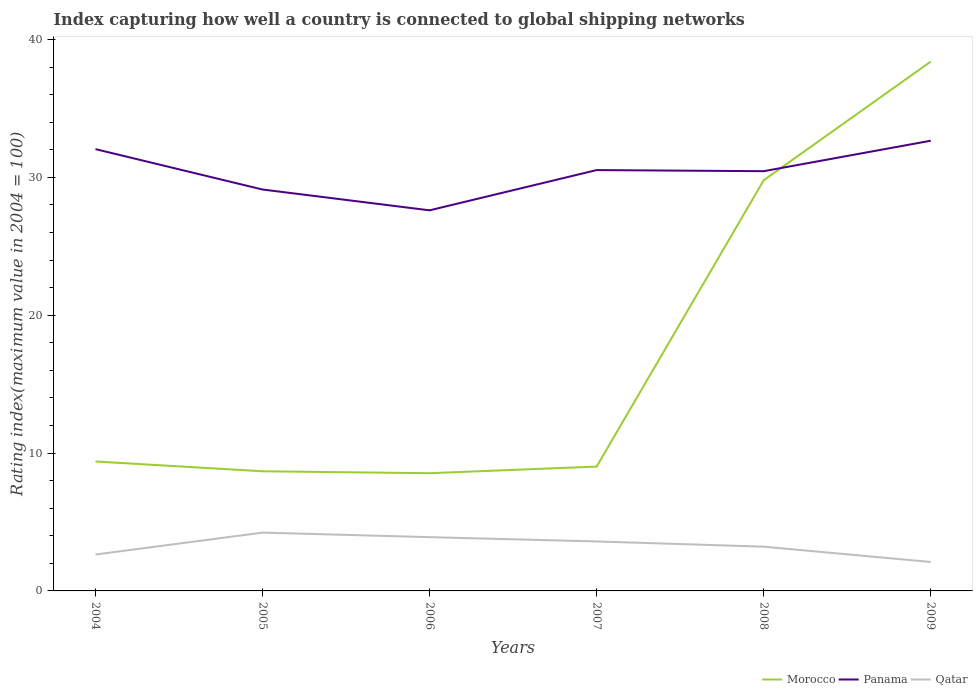How many different coloured lines are there?
Ensure brevity in your answer.  3. Does the line corresponding to Morocco intersect with the line corresponding to Panama?
Provide a succinct answer. Yes. Is the number of lines equal to the number of legend labels?
Your answer should be very brief. Yes. Across all years, what is the maximum rating index in Panama?
Make the answer very short. 27.61. In which year was the rating index in Panama maximum?
Ensure brevity in your answer.  2006. What is the total rating index in Panama in the graph?
Offer a terse response. -2.92. What is the difference between the highest and the second highest rating index in Qatar?
Your response must be concise. 2.13. What is the difference between the highest and the lowest rating index in Qatar?
Offer a very short reply. 3. Is the rating index in Morocco strictly greater than the rating index in Panama over the years?
Keep it short and to the point. No. How many years are there in the graph?
Offer a terse response. 6. What is the difference between two consecutive major ticks on the Y-axis?
Keep it short and to the point. 10. Are the values on the major ticks of Y-axis written in scientific E-notation?
Your response must be concise. No. Does the graph contain grids?
Offer a terse response. No. How many legend labels are there?
Offer a very short reply. 3. How are the legend labels stacked?
Give a very brief answer. Horizontal. What is the title of the graph?
Keep it short and to the point. Index capturing how well a country is connected to global shipping networks. What is the label or title of the X-axis?
Provide a short and direct response. Years. What is the label or title of the Y-axis?
Ensure brevity in your answer.  Rating index(maximum value in 2004 = 100). What is the Rating index(maximum value in 2004 = 100) of Morocco in 2004?
Provide a succinct answer. 9.39. What is the Rating index(maximum value in 2004 = 100) of Panama in 2004?
Offer a terse response. 32.05. What is the Rating index(maximum value in 2004 = 100) of Qatar in 2004?
Your answer should be very brief. 2.64. What is the Rating index(maximum value in 2004 = 100) in Morocco in 2005?
Provide a succinct answer. 8.68. What is the Rating index(maximum value in 2004 = 100) in Panama in 2005?
Offer a very short reply. 29.12. What is the Rating index(maximum value in 2004 = 100) in Qatar in 2005?
Give a very brief answer. 4.23. What is the Rating index(maximum value in 2004 = 100) of Morocco in 2006?
Your answer should be very brief. 8.54. What is the Rating index(maximum value in 2004 = 100) in Panama in 2006?
Offer a very short reply. 27.61. What is the Rating index(maximum value in 2004 = 100) of Qatar in 2006?
Your response must be concise. 3.9. What is the Rating index(maximum value in 2004 = 100) of Morocco in 2007?
Your answer should be very brief. 9.02. What is the Rating index(maximum value in 2004 = 100) of Panama in 2007?
Provide a short and direct response. 30.53. What is the Rating index(maximum value in 2004 = 100) in Qatar in 2007?
Keep it short and to the point. 3.59. What is the Rating index(maximum value in 2004 = 100) in Morocco in 2008?
Give a very brief answer. 29.79. What is the Rating index(maximum value in 2004 = 100) in Panama in 2008?
Make the answer very short. 30.45. What is the Rating index(maximum value in 2004 = 100) of Qatar in 2008?
Your response must be concise. 3.21. What is the Rating index(maximum value in 2004 = 100) of Morocco in 2009?
Offer a very short reply. 38.4. What is the Rating index(maximum value in 2004 = 100) in Panama in 2009?
Keep it short and to the point. 32.66. What is the Rating index(maximum value in 2004 = 100) of Qatar in 2009?
Your answer should be very brief. 2.1. Across all years, what is the maximum Rating index(maximum value in 2004 = 100) of Morocco?
Provide a short and direct response. 38.4. Across all years, what is the maximum Rating index(maximum value in 2004 = 100) of Panama?
Ensure brevity in your answer.  32.66. Across all years, what is the maximum Rating index(maximum value in 2004 = 100) in Qatar?
Give a very brief answer. 4.23. Across all years, what is the minimum Rating index(maximum value in 2004 = 100) in Morocco?
Provide a succinct answer. 8.54. Across all years, what is the minimum Rating index(maximum value in 2004 = 100) of Panama?
Keep it short and to the point. 27.61. What is the total Rating index(maximum value in 2004 = 100) in Morocco in the graph?
Provide a short and direct response. 103.82. What is the total Rating index(maximum value in 2004 = 100) of Panama in the graph?
Offer a terse response. 182.42. What is the total Rating index(maximum value in 2004 = 100) in Qatar in the graph?
Keep it short and to the point. 19.67. What is the difference between the Rating index(maximum value in 2004 = 100) of Morocco in 2004 and that in 2005?
Keep it short and to the point. 0.71. What is the difference between the Rating index(maximum value in 2004 = 100) in Panama in 2004 and that in 2005?
Give a very brief answer. 2.93. What is the difference between the Rating index(maximum value in 2004 = 100) in Qatar in 2004 and that in 2005?
Offer a terse response. -1.59. What is the difference between the Rating index(maximum value in 2004 = 100) of Panama in 2004 and that in 2006?
Your answer should be very brief. 4.44. What is the difference between the Rating index(maximum value in 2004 = 100) of Qatar in 2004 and that in 2006?
Offer a very short reply. -1.26. What is the difference between the Rating index(maximum value in 2004 = 100) in Morocco in 2004 and that in 2007?
Ensure brevity in your answer.  0.37. What is the difference between the Rating index(maximum value in 2004 = 100) in Panama in 2004 and that in 2007?
Offer a terse response. 1.52. What is the difference between the Rating index(maximum value in 2004 = 100) in Qatar in 2004 and that in 2007?
Your answer should be compact. -0.95. What is the difference between the Rating index(maximum value in 2004 = 100) of Morocco in 2004 and that in 2008?
Offer a very short reply. -20.4. What is the difference between the Rating index(maximum value in 2004 = 100) of Qatar in 2004 and that in 2008?
Offer a very short reply. -0.57. What is the difference between the Rating index(maximum value in 2004 = 100) of Morocco in 2004 and that in 2009?
Your answer should be very brief. -29.01. What is the difference between the Rating index(maximum value in 2004 = 100) of Panama in 2004 and that in 2009?
Provide a short and direct response. -0.61. What is the difference between the Rating index(maximum value in 2004 = 100) in Qatar in 2004 and that in 2009?
Your answer should be very brief. 0.54. What is the difference between the Rating index(maximum value in 2004 = 100) of Morocco in 2005 and that in 2006?
Give a very brief answer. 0.14. What is the difference between the Rating index(maximum value in 2004 = 100) of Panama in 2005 and that in 2006?
Give a very brief answer. 1.51. What is the difference between the Rating index(maximum value in 2004 = 100) of Qatar in 2005 and that in 2006?
Offer a terse response. 0.33. What is the difference between the Rating index(maximum value in 2004 = 100) of Morocco in 2005 and that in 2007?
Give a very brief answer. -0.34. What is the difference between the Rating index(maximum value in 2004 = 100) of Panama in 2005 and that in 2007?
Offer a very short reply. -1.41. What is the difference between the Rating index(maximum value in 2004 = 100) in Qatar in 2005 and that in 2007?
Give a very brief answer. 0.64. What is the difference between the Rating index(maximum value in 2004 = 100) in Morocco in 2005 and that in 2008?
Your answer should be very brief. -21.11. What is the difference between the Rating index(maximum value in 2004 = 100) in Panama in 2005 and that in 2008?
Your answer should be compact. -1.33. What is the difference between the Rating index(maximum value in 2004 = 100) of Qatar in 2005 and that in 2008?
Provide a succinct answer. 1.02. What is the difference between the Rating index(maximum value in 2004 = 100) of Morocco in 2005 and that in 2009?
Keep it short and to the point. -29.72. What is the difference between the Rating index(maximum value in 2004 = 100) in Panama in 2005 and that in 2009?
Make the answer very short. -3.54. What is the difference between the Rating index(maximum value in 2004 = 100) in Qatar in 2005 and that in 2009?
Offer a terse response. 2.13. What is the difference between the Rating index(maximum value in 2004 = 100) in Morocco in 2006 and that in 2007?
Your response must be concise. -0.48. What is the difference between the Rating index(maximum value in 2004 = 100) of Panama in 2006 and that in 2007?
Keep it short and to the point. -2.92. What is the difference between the Rating index(maximum value in 2004 = 100) of Qatar in 2006 and that in 2007?
Offer a terse response. 0.31. What is the difference between the Rating index(maximum value in 2004 = 100) in Morocco in 2006 and that in 2008?
Your response must be concise. -21.25. What is the difference between the Rating index(maximum value in 2004 = 100) in Panama in 2006 and that in 2008?
Your response must be concise. -2.84. What is the difference between the Rating index(maximum value in 2004 = 100) in Qatar in 2006 and that in 2008?
Offer a terse response. 0.69. What is the difference between the Rating index(maximum value in 2004 = 100) of Morocco in 2006 and that in 2009?
Ensure brevity in your answer.  -29.86. What is the difference between the Rating index(maximum value in 2004 = 100) of Panama in 2006 and that in 2009?
Offer a very short reply. -5.05. What is the difference between the Rating index(maximum value in 2004 = 100) in Morocco in 2007 and that in 2008?
Ensure brevity in your answer.  -20.77. What is the difference between the Rating index(maximum value in 2004 = 100) in Qatar in 2007 and that in 2008?
Ensure brevity in your answer.  0.38. What is the difference between the Rating index(maximum value in 2004 = 100) in Morocco in 2007 and that in 2009?
Make the answer very short. -29.38. What is the difference between the Rating index(maximum value in 2004 = 100) of Panama in 2007 and that in 2009?
Offer a terse response. -2.13. What is the difference between the Rating index(maximum value in 2004 = 100) in Qatar in 2007 and that in 2009?
Ensure brevity in your answer.  1.49. What is the difference between the Rating index(maximum value in 2004 = 100) in Morocco in 2008 and that in 2009?
Provide a succinct answer. -8.61. What is the difference between the Rating index(maximum value in 2004 = 100) in Panama in 2008 and that in 2009?
Offer a terse response. -2.21. What is the difference between the Rating index(maximum value in 2004 = 100) of Qatar in 2008 and that in 2009?
Your answer should be very brief. 1.11. What is the difference between the Rating index(maximum value in 2004 = 100) in Morocco in 2004 and the Rating index(maximum value in 2004 = 100) in Panama in 2005?
Give a very brief answer. -19.73. What is the difference between the Rating index(maximum value in 2004 = 100) of Morocco in 2004 and the Rating index(maximum value in 2004 = 100) of Qatar in 2005?
Give a very brief answer. 5.16. What is the difference between the Rating index(maximum value in 2004 = 100) in Panama in 2004 and the Rating index(maximum value in 2004 = 100) in Qatar in 2005?
Your response must be concise. 27.82. What is the difference between the Rating index(maximum value in 2004 = 100) in Morocco in 2004 and the Rating index(maximum value in 2004 = 100) in Panama in 2006?
Your answer should be compact. -18.22. What is the difference between the Rating index(maximum value in 2004 = 100) of Morocco in 2004 and the Rating index(maximum value in 2004 = 100) of Qatar in 2006?
Provide a short and direct response. 5.49. What is the difference between the Rating index(maximum value in 2004 = 100) of Panama in 2004 and the Rating index(maximum value in 2004 = 100) of Qatar in 2006?
Provide a short and direct response. 28.15. What is the difference between the Rating index(maximum value in 2004 = 100) of Morocco in 2004 and the Rating index(maximum value in 2004 = 100) of Panama in 2007?
Keep it short and to the point. -21.14. What is the difference between the Rating index(maximum value in 2004 = 100) in Panama in 2004 and the Rating index(maximum value in 2004 = 100) in Qatar in 2007?
Your answer should be very brief. 28.46. What is the difference between the Rating index(maximum value in 2004 = 100) of Morocco in 2004 and the Rating index(maximum value in 2004 = 100) of Panama in 2008?
Offer a very short reply. -21.06. What is the difference between the Rating index(maximum value in 2004 = 100) in Morocco in 2004 and the Rating index(maximum value in 2004 = 100) in Qatar in 2008?
Your answer should be compact. 6.18. What is the difference between the Rating index(maximum value in 2004 = 100) of Panama in 2004 and the Rating index(maximum value in 2004 = 100) of Qatar in 2008?
Offer a terse response. 28.84. What is the difference between the Rating index(maximum value in 2004 = 100) of Morocco in 2004 and the Rating index(maximum value in 2004 = 100) of Panama in 2009?
Your response must be concise. -23.27. What is the difference between the Rating index(maximum value in 2004 = 100) in Morocco in 2004 and the Rating index(maximum value in 2004 = 100) in Qatar in 2009?
Your response must be concise. 7.29. What is the difference between the Rating index(maximum value in 2004 = 100) of Panama in 2004 and the Rating index(maximum value in 2004 = 100) of Qatar in 2009?
Offer a terse response. 29.95. What is the difference between the Rating index(maximum value in 2004 = 100) of Morocco in 2005 and the Rating index(maximum value in 2004 = 100) of Panama in 2006?
Provide a succinct answer. -18.93. What is the difference between the Rating index(maximum value in 2004 = 100) of Morocco in 2005 and the Rating index(maximum value in 2004 = 100) of Qatar in 2006?
Provide a succinct answer. 4.78. What is the difference between the Rating index(maximum value in 2004 = 100) of Panama in 2005 and the Rating index(maximum value in 2004 = 100) of Qatar in 2006?
Give a very brief answer. 25.22. What is the difference between the Rating index(maximum value in 2004 = 100) in Morocco in 2005 and the Rating index(maximum value in 2004 = 100) in Panama in 2007?
Provide a succinct answer. -21.85. What is the difference between the Rating index(maximum value in 2004 = 100) in Morocco in 2005 and the Rating index(maximum value in 2004 = 100) in Qatar in 2007?
Provide a succinct answer. 5.09. What is the difference between the Rating index(maximum value in 2004 = 100) of Panama in 2005 and the Rating index(maximum value in 2004 = 100) of Qatar in 2007?
Ensure brevity in your answer.  25.53. What is the difference between the Rating index(maximum value in 2004 = 100) of Morocco in 2005 and the Rating index(maximum value in 2004 = 100) of Panama in 2008?
Keep it short and to the point. -21.77. What is the difference between the Rating index(maximum value in 2004 = 100) of Morocco in 2005 and the Rating index(maximum value in 2004 = 100) of Qatar in 2008?
Your answer should be compact. 5.47. What is the difference between the Rating index(maximum value in 2004 = 100) of Panama in 2005 and the Rating index(maximum value in 2004 = 100) of Qatar in 2008?
Your answer should be compact. 25.91. What is the difference between the Rating index(maximum value in 2004 = 100) in Morocco in 2005 and the Rating index(maximum value in 2004 = 100) in Panama in 2009?
Offer a very short reply. -23.98. What is the difference between the Rating index(maximum value in 2004 = 100) of Morocco in 2005 and the Rating index(maximum value in 2004 = 100) of Qatar in 2009?
Make the answer very short. 6.58. What is the difference between the Rating index(maximum value in 2004 = 100) of Panama in 2005 and the Rating index(maximum value in 2004 = 100) of Qatar in 2009?
Offer a terse response. 27.02. What is the difference between the Rating index(maximum value in 2004 = 100) in Morocco in 2006 and the Rating index(maximum value in 2004 = 100) in Panama in 2007?
Give a very brief answer. -21.99. What is the difference between the Rating index(maximum value in 2004 = 100) of Morocco in 2006 and the Rating index(maximum value in 2004 = 100) of Qatar in 2007?
Your response must be concise. 4.95. What is the difference between the Rating index(maximum value in 2004 = 100) in Panama in 2006 and the Rating index(maximum value in 2004 = 100) in Qatar in 2007?
Provide a short and direct response. 24.02. What is the difference between the Rating index(maximum value in 2004 = 100) of Morocco in 2006 and the Rating index(maximum value in 2004 = 100) of Panama in 2008?
Your answer should be compact. -21.91. What is the difference between the Rating index(maximum value in 2004 = 100) of Morocco in 2006 and the Rating index(maximum value in 2004 = 100) of Qatar in 2008?
Your answer should be compact. 5.33. What is the difference between the Rating index(maximum value in 2004 = 100) of Panama in 2006 and the Rating index(maximum value in 2004 = 100) of Qatar in 2008?
Your answer should be very brief. 24.4. What is the difference between the Rating index(maximum value in 2004 = 100) of Morocco in 2006 and the Rating index(maximum value in 2004 = 100) of Panama in 2009?
Your answer should be compact. -24.12. What is the difference between the Rating index(maximum value in 2004 = 100) in Morocco in 2006 and the Rating index(maximum value in 2004 = 100) in Qatar in 2009?
Provide a succinct answer. 6.44. What is the difference between the Rating index(maximum value in 2004 = 100) of Panama in 2006 and the Rating index(maximum value in 2004 = 100) of Qatar in 2009?
Your answer should be compact. 25.51. What is the difference between the Rating index(maximum value in 2004 = 100) of Morocco in 2007 and the Rating index(maximum value in 2004 = 100) of Panama in 2008?
Provide a short and direct response. -21.43. What is the difference between the Rating index(maximum value in 2004 = 100) in Morocco in 2007 and the Rating index(maximum value in 2004 = 100) in Qatar in 2008?
Your response must be concise. 5.81. What is the difference between the Rating index(maximum value in 2004 = 100) in Panama in 2007 and the Rating index(maximum value in 2004 = 100) in Qatar in 2008?
Ensure brevity in your answer.  27.32. What is the difference between the Rating index(maximum value in 2004 = 100) of Morocco in 2007 and the Rating index(maximum value in 2004 = 100) of Panama in 2009?
Provide a succinct answer. -23.64. What is the difference between the Rating index(maximum value in 2004 = 100) of Morocco in 2007 and the Rating index(maximum value in 2004 = 100) of Qatar in 2009?
Your answer should be compact. 6.92. What is the difference between the Rating index(maximum value in 2004 = 100) in Panama in 2007 and the Rating index(maximum value in 2004 = 100) in Qatar in 2009?
Your response must be concise. 28.43. What is the difference between the Rating index(maximum value in 2004 = 100) in Morocco in 2008 and the Rating index(maximum value in 2004 = 100) in Panama in 2009?
Offer a very short reply. -2.87. What is the difference between the Rating index(maximum value in 2004 = 100) in Morocco in 2008 and the Rating index(maximum value in 2004 = 100) in Qatar in 2009?
Give a very brief answer. 27.69. What is the difference between the Rating index(maximum value in 2004 = 100) in Panama in 2008 and the Rating index(maximum value in 2004 = 100) in Qatar in 2009?
Offer a terse response. 28.35. What is the average Rating index(maximum value in 2004 = 100) of Morocco per year?
Offer a very short reply. 17.3. What is the average Rating index(maximum value in 2004 = 100) in Panama per year?
Keep it short and to the point. 30.4. What is the average Rating index(maximum value in 2004 = 100) in Qatar per year?
Offer a very short reply. 3.28. In the year 2004, what is the difference between the Rating index(maximum value in 2004 = 100) in Morocco and Rating index(maximum value in 2004 = 100) in Panama?
Make the answer very short. -22.66. In the year 2004, what is the difference between the Rating index(maximum value in 2004 = 100) of Morocco and Rating index(maximum value in 2004 = 100) of Qatar?
Keep it short and to the point. 6.75. In the year 2004, what is the difference between the Rating index(maximum value in 2004 = 100) in Panama and Rating index(maximum value in 2004 = 100) in Qatar?
Your answer should be compact. 29.41. In the year 2005, what is the difference between the Rating index(maximum value in 2004 = 100) in Morocco and Rating index(maximum value in 2004 = 100) in Panama?
Your answer should be compact. -20.44. In the year 2005, what is the difference between the Rating index(maximum value in 2004 = 100) in Morocco and Rating index(maximum value in 2004 = 100) in Qatar?
Ensure brevity in your answer.  4.45. In the year 2005, what is the difference between the Rating index(maximum value in 2004 = 100) of Panama and Rating index(maximum value in 2004 = 100) of Qatar?
Provide a succinct answer. 24.89. In the year 2006, what is the difference between the Rating index(maximum value in 2004 = 100) of Morocco and Rating index(maximum value in 2004 = 100) of Panama?
Your answer should be very brief. -19.07. In the year 2006, what is the difference between the Rating index(maximum value in 2004 = 100) of Morocco and Rating index(maximum value in 2004 = 100) of Qatar?
Give a very brief answer. 4.64. In the year 2006, what is the difference between the Rating index(maximum value in 2004 = 100) of Panama and Rating index(maximum value in 2004 = 100) of Qatar?
Your answer should be very brief. 23.71. In the year 2007, what is the difference between the Rating index(maximum value in 2004 = 100) of Morocco and Rating index(maximum value in 2004 = 100) of Panama?
Make the answer very short. -21.51. In the year 2007, what is the difference between the Rating index(maximum value in 2004 = 100) of Morocco and Rating index(maximum value in 2004 = 100) of Qatar?
Provide a short and direct response. 5.43. In the year 2007, what is the difference between the Rating index(maximum value in 2004 = 100) in Panama and Rating index(maximum value in 2004 = 100) in Qatar?
Ensure brevity in your answer.  26.94. In the year 2008, what is the difference between the Rating index(maximum value in 2004 = 100) of Morocco and Rating index(maximum value in 2004 = 100) of Panama?
Give a very brief answer. -0.66. In the year 2008, what is the difference between the Rating index(maximum value in 2004 = 100) in Morocco and Rating index(maximum value in 2004 = 100) in Qatar?
Your response must be concise. 26.58. In the year 2008, what is the difference between the Rating index(maximum value in 2004 = 100) of Panama and Rating index(maximum value in 2004 = 100) of Qatar?
Your answer should be very brief. 27.24. In the year 2009, what is the difference between the Rating index(maximum value in 2004 = 100) of Morocco and Rating index(maximum value in 2004 = 100) of Panama?
Offer a very short reply. 5.74. In the year 2009, what is the difference between the Rating index(maximum value in 2004 = 100) in Morocco and Rating index(maximum value in 2004 = 100) in Qatar?
Ensure brevity in your answer.  36.3. In the year 2009, what is the difference between the Rating index(maximum value in 2004 = 100) of Panama and Rating index(maximum value in 2004 = 100) of Qatar?
Offer a terse response. 30.56. What is the ratio of the Rating index(maximum value in 2004 = 100) of Morocco in 2004 to that in 2005?
Offer a terse response. 1.08. What is the ratio of the Rating index(maximum value in 2004 = 100) of Panama in 2004 to that in 2005?
Give a very brief answer. 1.1. What is the ratio of the Rating index(maximum value in 2004 = 100) in Qatar in 2004 to that in 2005?
Provide a short and direct response. 0.62. What is the ratio of the Rating index(maximum value in 2004 = 100) of Morocco in 2004 to that in 2006?
Your answer should be compact. 1.1. What is the ratio of the Rating index(maximum value in 2004 = 100) of Panama in 2004 to that in 2006?
Offer a terse response. 1.16. What is the ratio of the Rating index(maximum value in 2004 = 100) of Qatar in 2004 to that in 2006?
Offer a very short reply. 0.68. What is the ratio of the Rating index(maximum value in 2004 = 100) of Morocco in 2004 to that in 2007?
Make the answer very short. 1.04. What is the ratio of the Rating index(maximum value in 2004 = 100) of Panama in 2004 to that in 2007?
Make the answer very short. 1.05. What is the ratio of the Rating index(maximum value in 2004 = 100) in Qatar in 2004 to that in 2007?
Your response must be concise. 0.74. What is the ratio of the Rating index(maximum value in 2004 = 100) of Morocco in 2004 to that in 2008?
Provide a succinct answer. 0.32. What is the ratio of the Rating index(maximum value in 2004 = 100) of Panama in 2004 to that in 2008?
Offer a very short reply. 1.05. What is the ratio of the Rating index(maximum value in 2004 = 100) in Qatar in 2004 to that in 2008?
Your answer should be compact. 0.82. What is the ratio of the Rating index(maximum value in 2004 = 100) of Morocco in 2004 to that in 2009?
Provide a short and direct response. 0.24. What is the ratio of the Rating index(maximum value in 2004 = 100) of Panama in 2004 to that in 2009?
Offer a terse response. 0.98. What is the ratio of the Rating index(maximum value in 2004 = 100) in Qatar in 2004 to that in 2009?
Provide a short and direct response. 1.26. What is the ratio of the Rating index(maximum value in 2004 = 100) of Morocco in 2005 to that in 2006?
Offer a very short reply. 1.02. What is the ratio of the Rating index(maximum value in 2004 = 100) of Panama in 2005 to that in 2006?
Give a very brief answer. 1.05. What is the ratio of the Rating index(maximum value in 2004 = 100) of Qatar in 2005 to that in 2006?
Provide a short and direct response. 1.08. What is the ratio of the Rating index(maximum value in 2004 = 100) of Morocco in 2005 to that in 2007?
Offer a very short reply. 0.96. What is the ratio of the Rating index(maximum value in 2004 = 100) of Panama in 2005 to that in 2007?
Provide a succinct answer. 0.95. What is the ratio of the Rating index(maximum value in 2004 = 100) in Qatar in 2005 to that in 2007?
Your answer should be very brief. 1.18. What is the ratio of the Rating index(maximum value in 2004 = 100) in Morocco in 2005 to that in 2008?
Give a very brief answer. 0.29. What is the ratio of the Rating index(maximum value in 2004 = 100) of Panama in 2005 to that in 2008?
Provide a succinct answer. 0.96. What is the ratio of the Rating index(maximum value in 2004 = 100) in Qatar in 2005 to that in 2008?
Make the answer very short. 1.32. What is the ratio of the Rating index(maximum value in 2004 = 100) of Morocco in 2005 to that in 2009?
Offer a very short reply. 0.23. What is the ratio of the Rating index(maximum value in 2004 = 100) in Panama in 2005 to that in 2009?
Offer a very short reply. 0.89. What is the ratio of the Rating index(maximum value in 2004 = 100) in Qatar in 2005 to that in 2009?
Offer a very short reply. 2.01. What is the ratio of the Rating index(maximum value in 2004 = 100) in Morocco in 2006 to that in 2007?
Offer a terse response. 0.95. What is the ratio of the Rating index(maximum value in 2004 = 100) in Panama in 2006 to that in 2007?
Offer a very short reply. 0.9. What is the ratio of the Rating index(maximum value in 2004 = 100) in Qatar in 2006 to that in 2007?
Offer a terse response. 1.09. What is the ratio of the Rating index(maximum value in 2004 = 100) of Morocco in 2006 to that in 2008?
Your response must be concise. 0.29. What is the ratio of the Rating index(maximum value in 2004 = 100) in Panama in 2006 to that in 2008?
Make the answer very short. 0.91. What is the ratio of the Rating index(maximum value in 2004 = 100) in Qatar in 2006 to that in 2008?
Offer a very short reply. 1.22. What is the ratio of the Rating index(maximum value in 2004 = 100) of Morocco in 2006 to that in 2009?
Make the answer very short. 0.22. What is the ratio of the Rating index(maximum value in 2004 = 100) of Panama in 2006 to that in 2009?
Provide a succinct answer. 0.85. What is the ratio of the Rating index(maximum value in 2004 = 100) of Qatar in 2006 to that in 2009?
Provide a succinct answer. 1.86. What is the ratio of the Rating index(maximum value in 2004 = 100) in Morocco in 2007 to that in 2008?
Your answer should be very brief. 0.3. What is the ratio of the Rating index(maximum value in 2004 = 100) in Panama in 2007 to that in 2008?
Provide a short and direct response. 1. What is the ratio of the Rating index(maximum value in 2004 = 100) in Qatar in 2007 to that in 2008?
Your answer should be very brief. 1.12. What is the ratio of the Rating index(maximum value in 2004 = 100) of Morocco in 2007 to that in 2009?
Your answer should be very brief. 0.23. What is the ratio of the Rating index(maximum value in 2004 = 100) in Panama in 2007 to that in 2009?
Offer a terse response. 0.93. What is the ratio of the Rating index(maximum value in 2004 = 100) of Qatar in 2007 to that in 2009?
Provide a succinct answer. 1.71. What is the ratio of the Rating index(maximum value in 2004 = 100) in Morocco in 2008 to that in 2009?
Offer a very short reply. 0.78. What is the ratio of the Rating index(maximum value in 2004 = 100) in Panama in 2008 to that in 2009?
Your answer should be compact. 0.93. What is the ratio of the Rating index(maximum value in 2004 = 100) of Qatar in 2008 to that in 2009?
Keep it short and to the point. 1.53. What is the difference between the highest and the second highest Rating index(maximum value in 2004 = 100) of Morocco?
Make the answer very short. 8.61. What is the difference between the highest and the second highest Rating index(maximum value in 2004 = 100) of Panama?
Give a very brief answer. 0.61. What is the difference between the highest and the second highest Rating index(maximum value in 2004 = 100) in Qatar?
Your answer should be compact. 0.33. What is the difference between the highest and the lowest Rating index(maximum value in 2004 = 100) in Morocco?
Your answer should be compact. 29.86. What is the difference between the highest and the lowest Rating index(maximum value in 2004 = 100) in Panama?
Your answer should be compact. 5.05. What is the difference between the highest and the lowest Rating index(maximum value in 2004 = 100) in Qatar?
Keep it short and to the point. 2.13. 